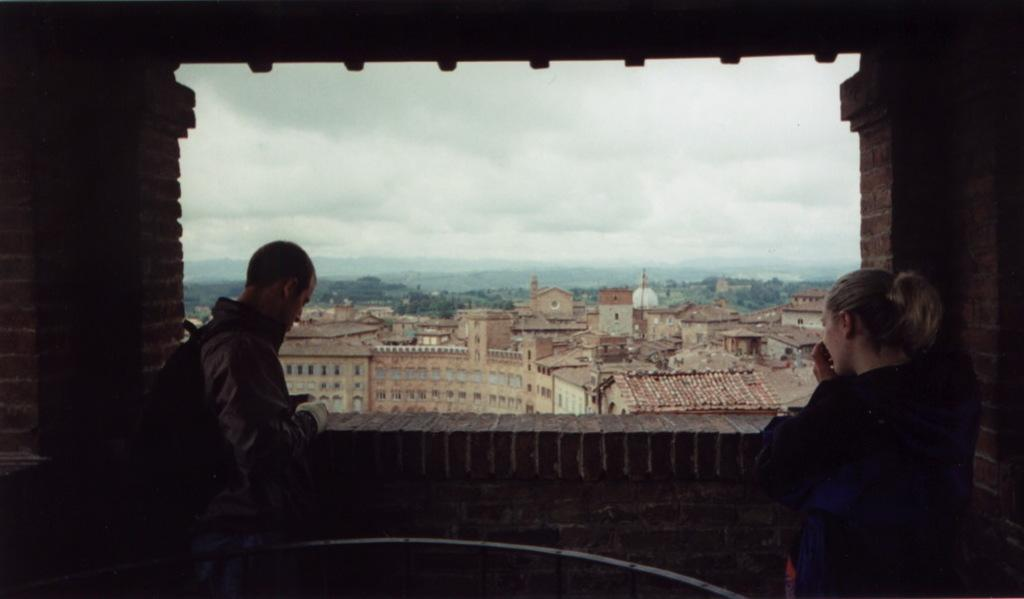How many people are in the image? There are two people in the image, a man and a woman. What are the man and woman doing in the image? The man and woman are standing. What can be seen through the window in the image? The image does not show what can be seen through the window. What is visible in the background of the image? Buildings and the sky are visible in the background of the image. What type of mask is the man wearing during the volleyball game in the image? There is no mask, volleyball game, or stage present in the image. 